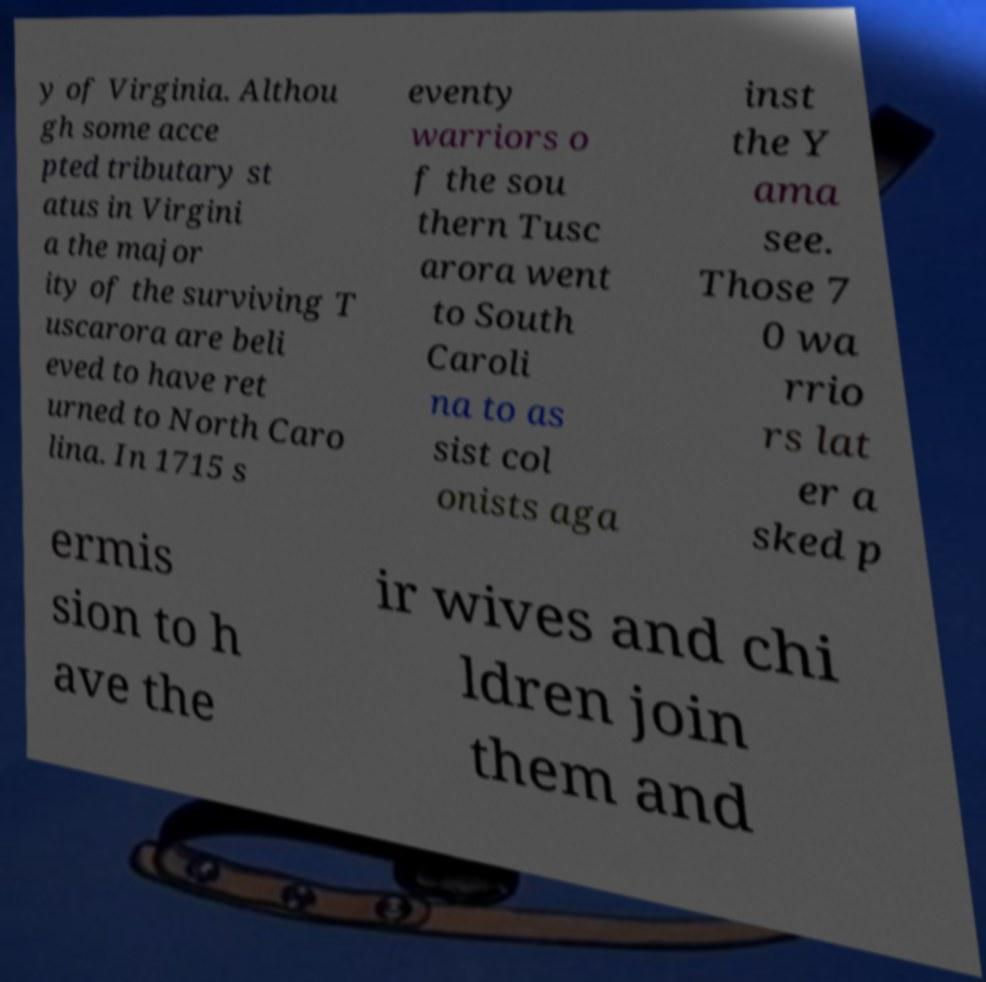Please identify and transcribe the text found in this image. y of Virginia. Althou gh some acce pted tributary st atus in Virgini a the major ity of the surviving T uscarora are beli eved to have ret urned to North Caro lina. In 1715 s eventy warriors o f the sou thern Tusc arora went to South Caroli na to as sist col onists aga inst the Y ama see. Those 7 0 wa rrio rs lat er a sked p ermis sion to h ave the ir wives and chi ldren join them and 